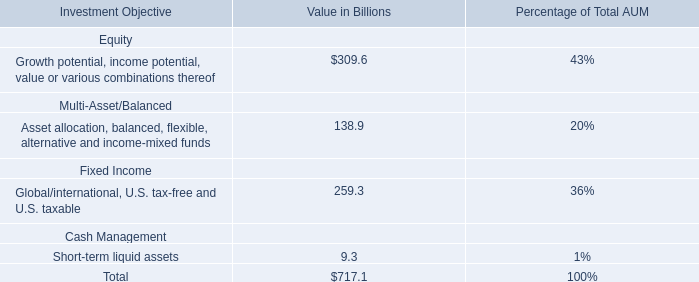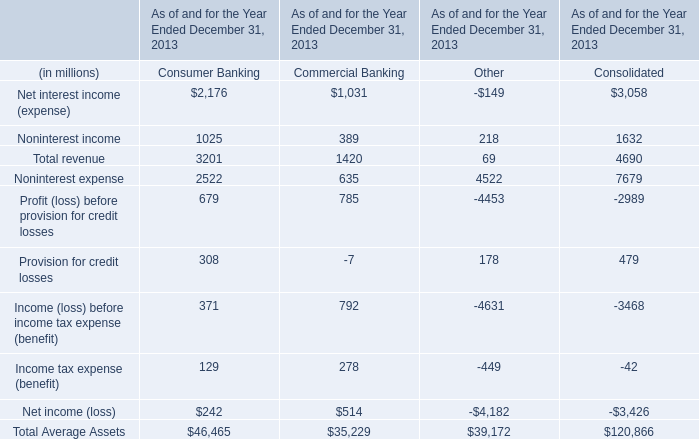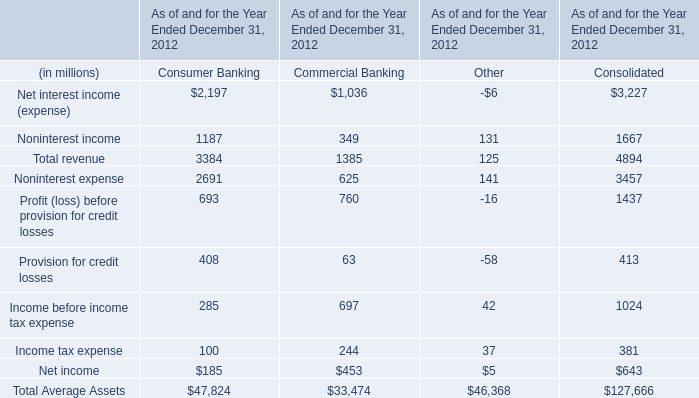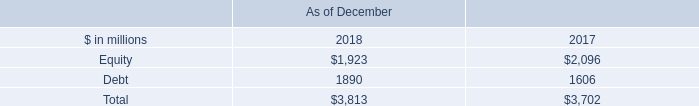Which Net interest income (expense) has the second largest number in 2012? 
Answer: Consolidated. 